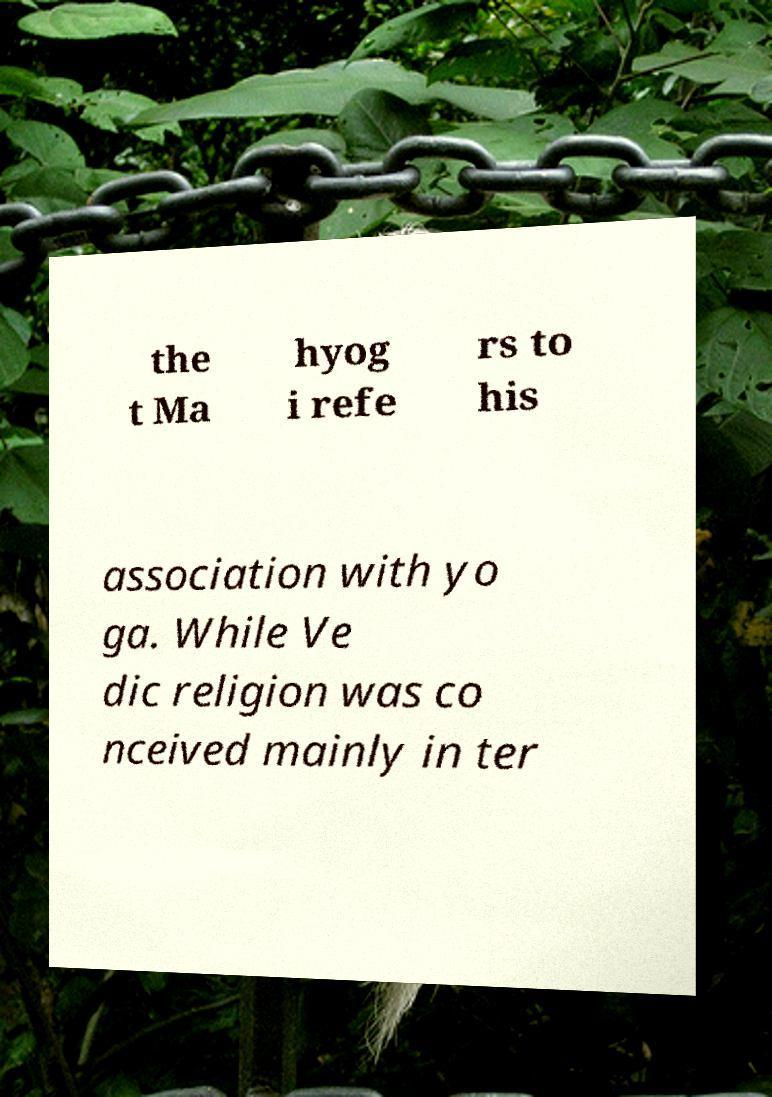Please read and relay the text visible in this image. What does it say? the t Ma hyog i refe rs to his association with yo ga. While Ve dic religion was co nceived mainly in ter 